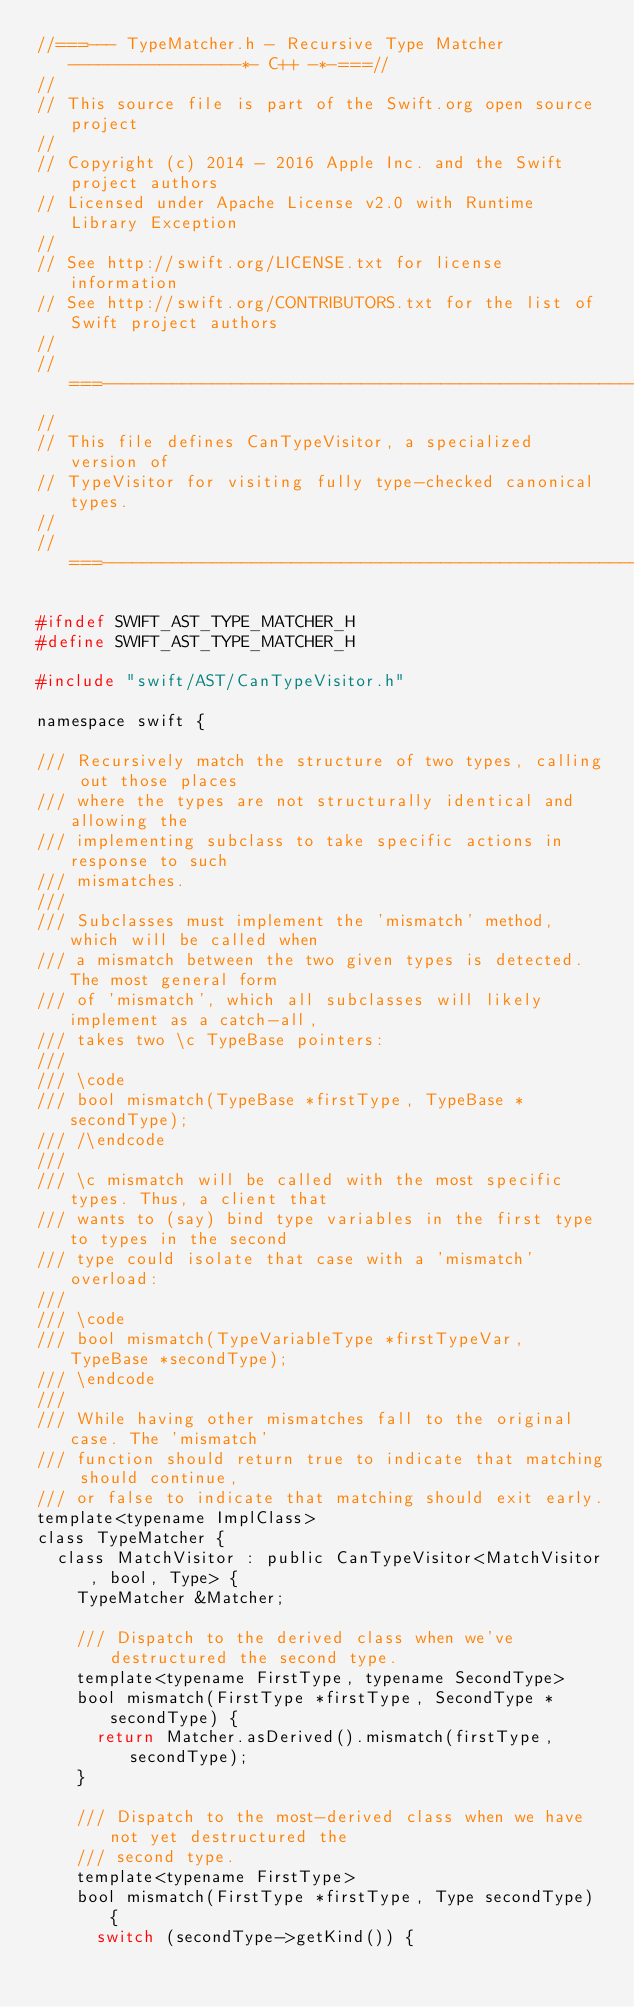<code> <loc_0><loc_0><loc_500><loc_500><_C_>//===--- TypeMatcher.h - Recursive Type Matcher -----------------*- C++ -*-===//
//
// This source file is part of the Swift.org open source project
//
// Copyright (c) 2014 - 2016 Apple Inc. and the Swift project authors
// Licensed under Apache License v2.0 with Runtime Library Exception
//
// See http://swift.org/LICENSE.txt for license information
// See http://swift.org/CONTRIBUTORS.txt for the list of Swift project authors
//
//===----------------------------------------------------------------------===//
//
// This file defines CanTypeVisitor, a specialized version of
// TypeVisitor for visiting fully type-checked canonical types.
//
//===----------------------------------------------------------------------===//

#ifndef SWIFT_AST_TYPE_MATCHER_H
#define SWIFT_AST_TYPE_MATCHER_H

#include "swift/AST/CanTypeVisitor.h"

namespace swift {

/// Recursively match the structure of two types, calling out those places
/// where the types are not structurally identical and allowing the
/// implementing subclass to take specific actions in response to such
/// mismatches.
///
/// Subclasses must implement the 'mismatch' method, which will be called when
/// a mismatch between the two given types is detected. The most general form
/// of 'mismatch', which all subclasses will likely implement as a catch-all,
/// takes two \c TypeBase pointers:
///
/// \code
/// bool mismatch(TypeBase *firstType, TypeBase *secondType);
/// /\endcode
///
/// \c mismatch will be called with the most specific types. Thus, a client that
/// wants to (say) bind type variables in the first type to types in the second
/// type could isolate that case with a 'mismatch' overload:
///
/// \code
/// bool mismatch(TypeVariableType *firstTypeVar, TypeBase *secondType);
/// \endcode
///
/// While having other mismatches fall to the original case. The 'mismatch'
/// function should return true to indicate that matching should continue,
/// or false to indicate that matching should exit early.
template<typename ImplClass>
class TypeMatcher {
  class MatchVisitor : public CanTypeVisitor<MatchVisitor, bool, Type> {
    TypeMatcher &Matcher;

    /// Dispatch to the derived class when we've destructured the second type.
    template<typename FirstType, typename SecondType>
    bool mismatch(FirstType *firstType, SecondType *secondType) {
      return Matcher.asDerived().mismatch(firstType, secondType);
    }

    /// Dispatch to the most-derived class when we have not yet destructured the
    /// second type.
    template<typename FirstType>
    bool mismatch(FirstType *firstType, Type secondType) {
      switch (secondType->getKind()) {</code> 